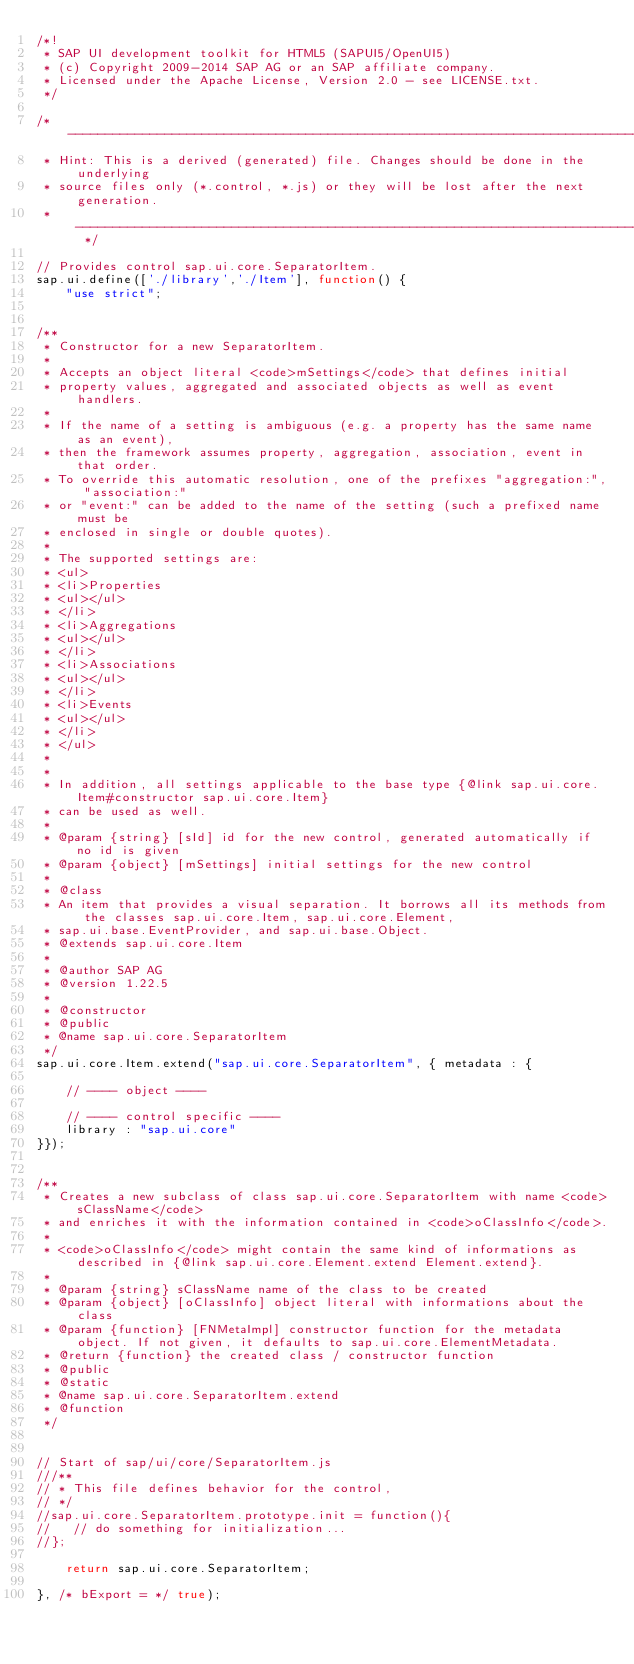<code> <loc_0><loc_0><loc_500><loc_500><_JavaScript_>/*!
 * SAP UI development toolkit for HTML5 (SAPUI5/OpenUI5)
 * (c) Copyright 2009-2014 SAP AG or an SAP affiliate company. 
 * Licensed under the Apache License, Version 2.0 - see LICENSE.txt.
 */

/* ----------------------------------------------------------------------------------
 * Hint: This is a derived (generated) file. Changes should be done in the underlying 
 * source files only (*.control, *.js) or they will be lost after the next generation.
 * ---------------------------------------------------------------------------------- */

// Provides control sap.ui.core.SeparatorItem.
sap.ui.define(['./library','./Item'], function() {
	"use strict";


/**
 * Constructor for a new SeparatorItem.
 * 
 * Accepts an object literal <code>mSettings</code> that defines initial 
 * property values, aggregated and associated objects as well as event handlers. 
 * 
 * If the name of a setting is ambiguous (e.g. a property has the same name as an event), 
 * then the framework assumes property, aggregation, association, event in that order. 
 * To override this automatic resolution, one of the prefixes "aggregation:", "association:" 
 * or "event:" can be added to the name of the setting (such a prefixed name must be
 * enclosed in single or double quotes).
 *
 * The supported settings are:
 * <ul>
 * <li>Properties
 * <ul></ul>
 * </li>
 * <li>Aggregations
 * <ul></ul>
 * </li>
 * <li>Associations
 * <ul></ul>
 * </li>
 * <li>Events
 * <ul></ul>
 * </li>
 * </ul> 
 *
 * 
 * In addition, all settings applicable to the base type {@link sap.ui.core.Item#constructor sap.ui.core.Item}
 * can be used as well.
 *
 * @param {string} [sId] id for the new control, generated automatically if no id is given 
 * @param {object} [mSettings] initial settings for the new control
 *
 * @class
 * An item that provides a visual separation. It borrows all its methods from the classes sap.ui.core.Item, sap.ui.core.Element,
 * sap.ui.base.EventProvider, and sap.ui.base.Object.
 * @extends sap.ui.core.Item
 *
 * @author SAP AG 
 * @version 1.22.5
 *
 * @constructor   
 * @public
 * @name sap.ui.core.SeparatorItem
 */
sap.ui.core.Item.extend("sap.ui.core.SeparatorItem", { metadata : {

	// ---- object ----

	// ---- control specific ----
	library : "sap.ui.core"
}});


/**
 * Creates a new subclass of class sap.ui.core.SeparatorItem with name <code>sClassName</code> 
 * and enriches it with the information contained in <code>oClassInfo</code>.
 * 
 * <code>oClassInfo</code> might contain the same kind of informations as described in {@link sap.ui.core.Element.extend Element.extend}.
 *   
 * @param {string} sClassName name of the class to be created
 * @param {object} [oClassInfo] object literal with informations about the class  
 * @param {function} [FNMetaImpl] constructor function for the metadata object. If not given, it defaults to sap.ui.core.ElementMetadata.
 * @return {function} the created class / constructor function
 * @public
 * @static
 * @name sap.ui.core.SeparatorItem.extend
 * @function
 */


// Start of sap/ui/core/SeparatorItem.js
///**
// * This file defines behavior for the control,
// */
//sap.ui.core.SeparatorItem.prototype.init = function(){
//   // do something for initialization...
//};

	return sap.ui.core.SeparatorItem;

}, /* bExport = */ true);
</code> 